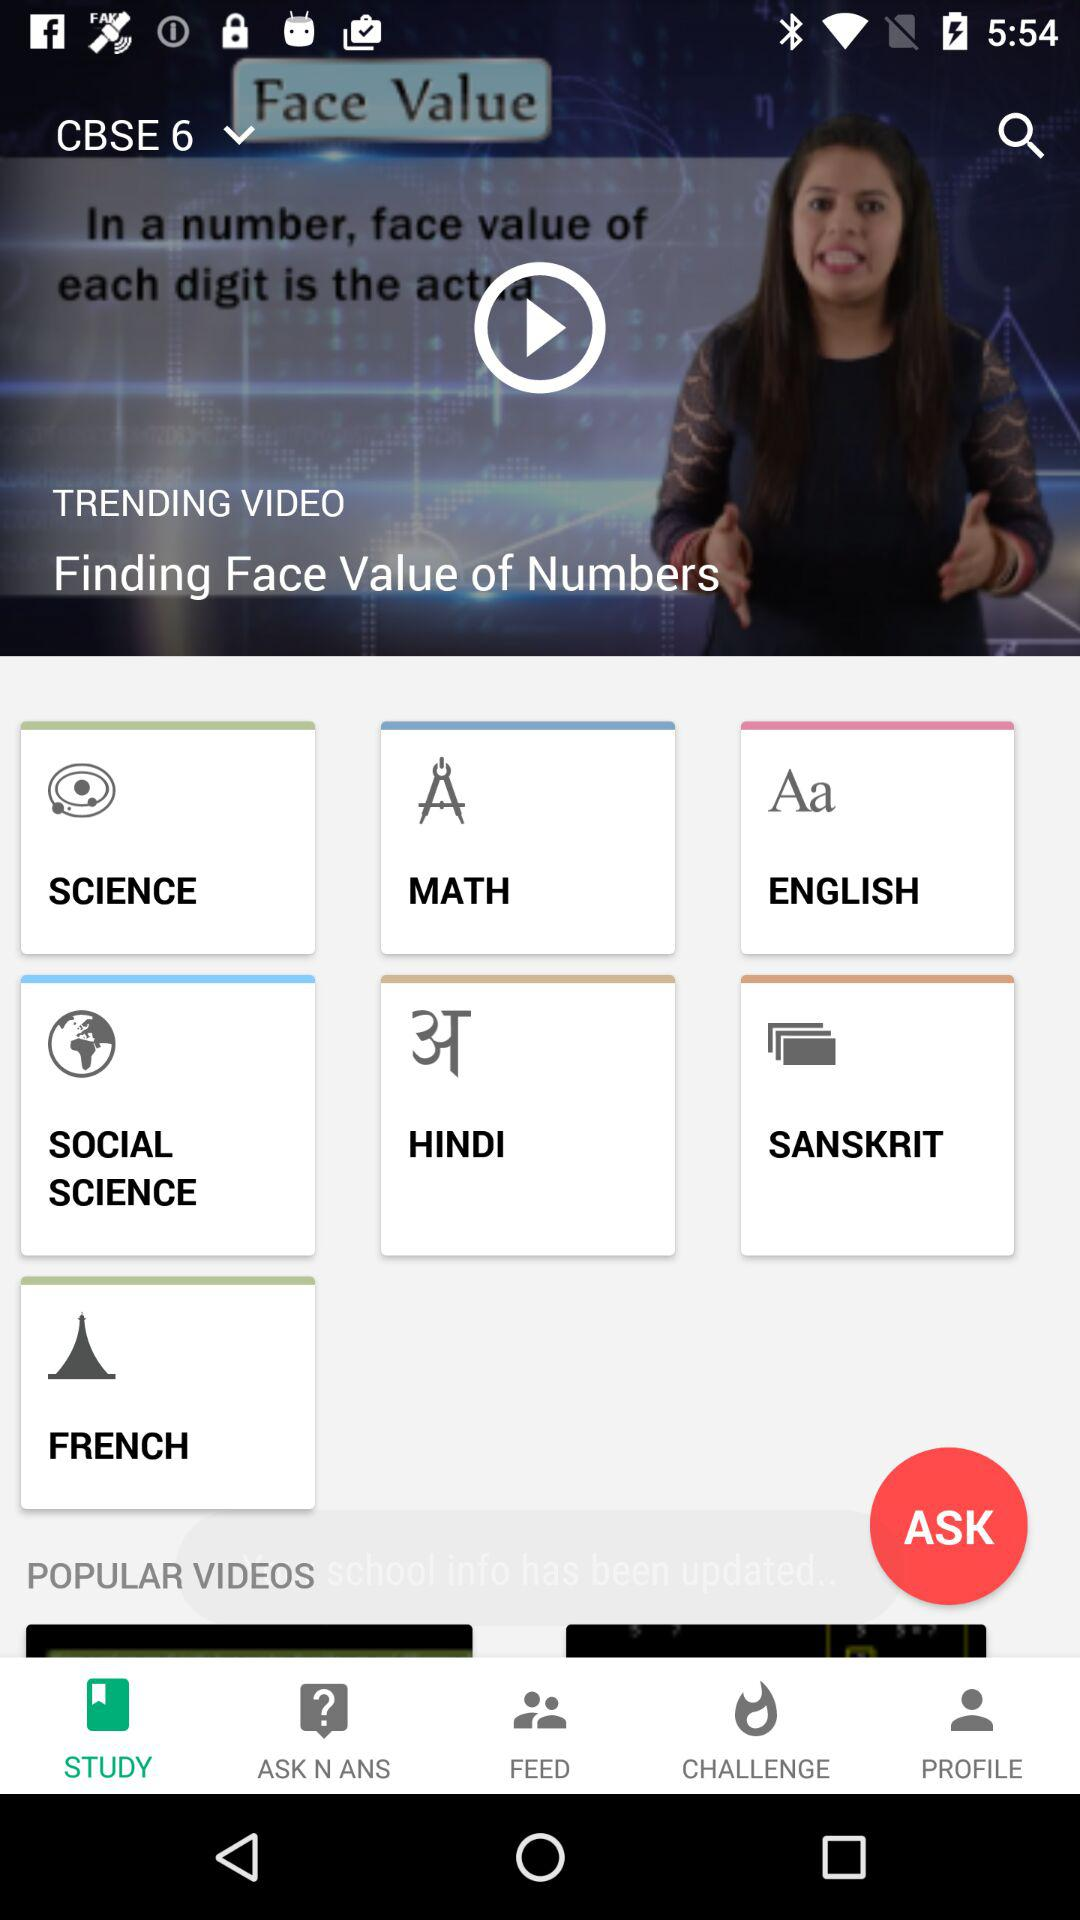What is the name of the trending video? The name of the trending video is "Finding Face Value of Numbers". 